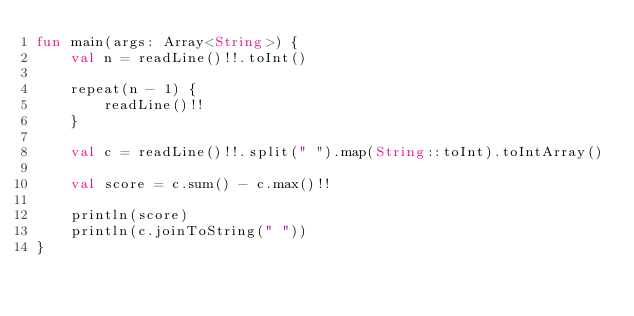Convert code to text. <code><loc_0><loc_0><loc_500><loc_500><_Kotlin_>fun main(args: Array<String>) {
    val n = readLine()!!.toInt()

    repeat(n - 1) {
        readLine()!!
    }

    val c = readLine()!!.split(" ").map(String::toInt).toIntArray()

    val score = c.sum() - c.max()!!

    println(score)
    println(c.joinToString(" "))
}
</code> 